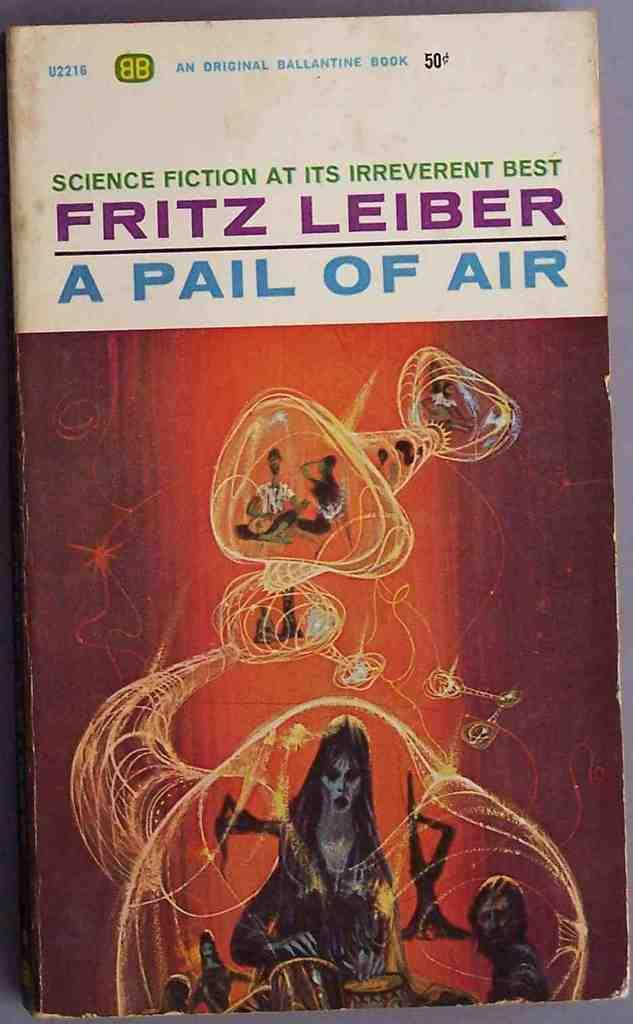<image>
Relay a brief, clear account of the picture shown. A science fiction novel by Fritz Leiber has a worn cover. 